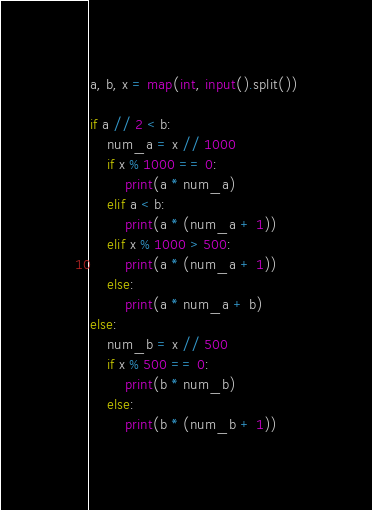<code> <loc_0><loc_0><loc_500><loc_500><_Python_>
a, b, x = map(int, input().split())

if a // 2 < b:
    num_a = x // 1000
    if x % 1000 == 0:
        print(a * num_a)
    elif a < b:
        print(a * (num_a + 1))
    elif x % 1000 > 500:
        print(a * (num_a + 1))
    else:
        print(a * num_a + b)
else:
    num_b = x // 500
    if x % 500 == 0:
        print(b * num_b)
    else:
        print(b * (num_b + 1))

</code> 